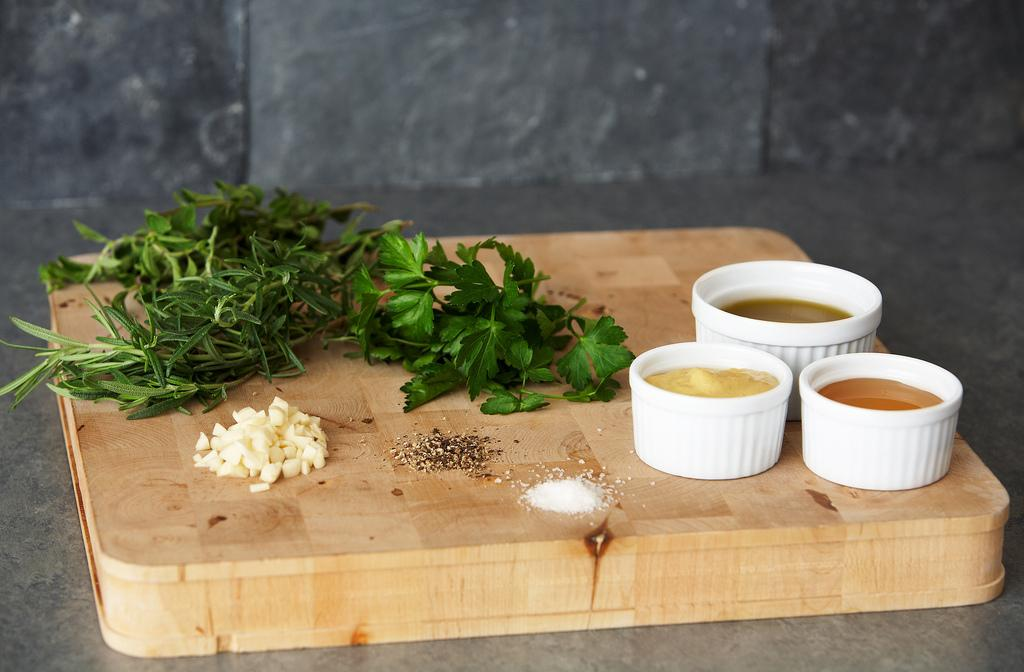What is the main object in the image? There is a wooden board in the image. What is placed on the wooden board? There are sauces, garlic, pepper, salt, thyme, and coriander on the wooden board. What can be seen in the background of the image? There is a wall in the background of the image. Who is the representative of the mist in the image? There is no mist or representative present in the image. What type of lunch is being prepared on the wooden board? The image does not show any lunch preparation; it only displays a wooden board with various ingredients and seasonings. 